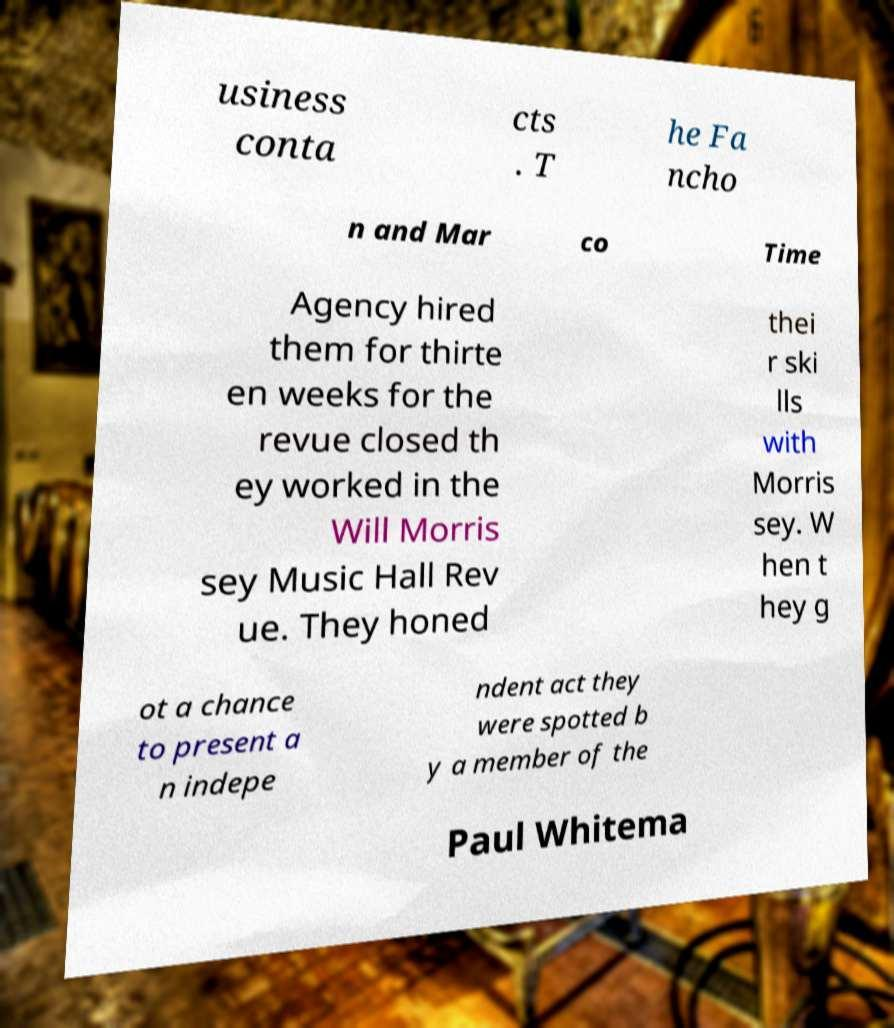Could you assist in decoding the text presented in this image and type it out clearly? usiness conta cts . T he Fa ncho n and Mar co Time Agency hired them for thirte en weeks for the revue closed th ey worked in the Will Morris sey Music Hall Rev ue. They honed thei r ski lls with Morris sey. W hen t hey g ot a chance to present a n indepe ndent act they were spotted b y a member of the Paul Whitema 